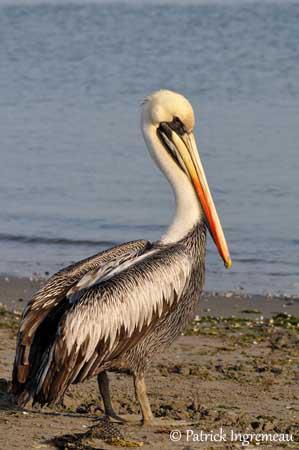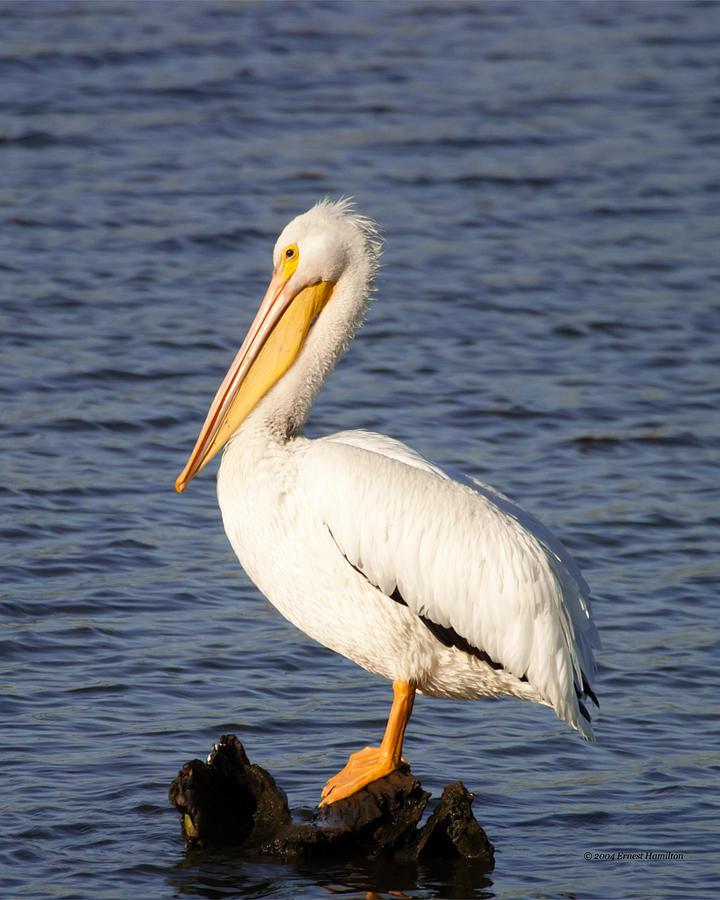The first image is the image on the left, the second image is the image on the right. Examine the images to the left and right. Is the description "One image depicts more than one water bird." accurate? Answer yes or no. No. 